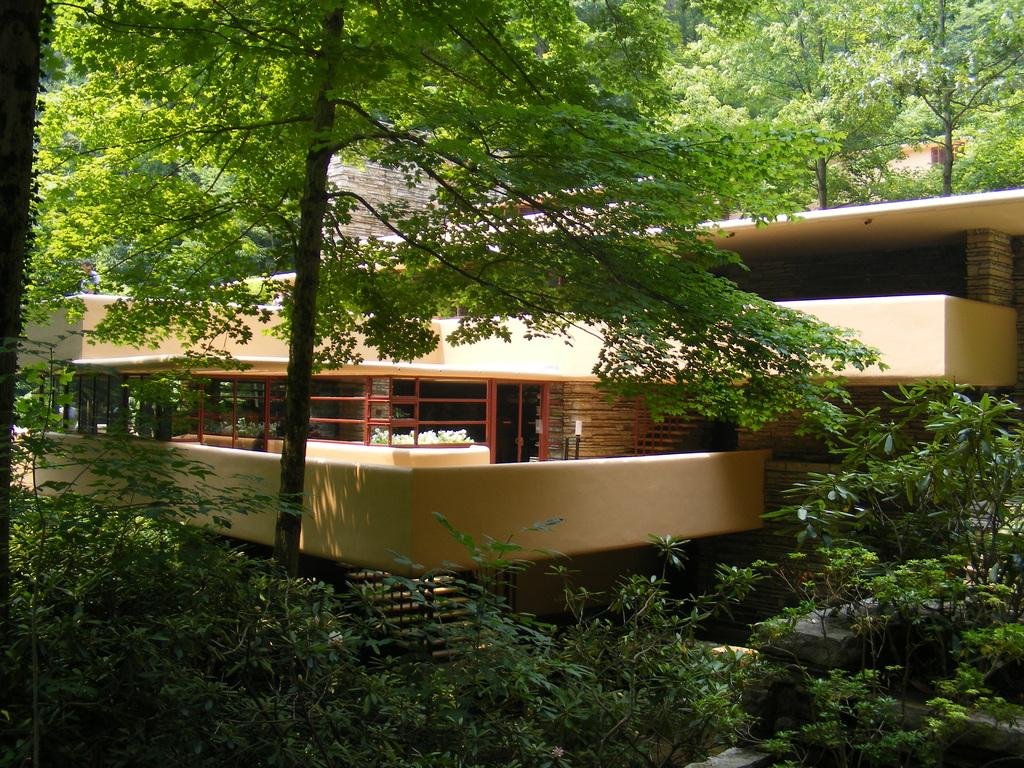What type of vegetation can be seen in the image? There are trees in the image. What type of structure is visible in the image? There is a building in the image. How many planes are flying over the trees in the image? There are no planes visible in the image; it only features trees and a building. What type of stitch is used to connect the branches of the trees in the image? The image is a photograph, not a drawing or painting, so there is no stitching involved in the depiction of the trees. 